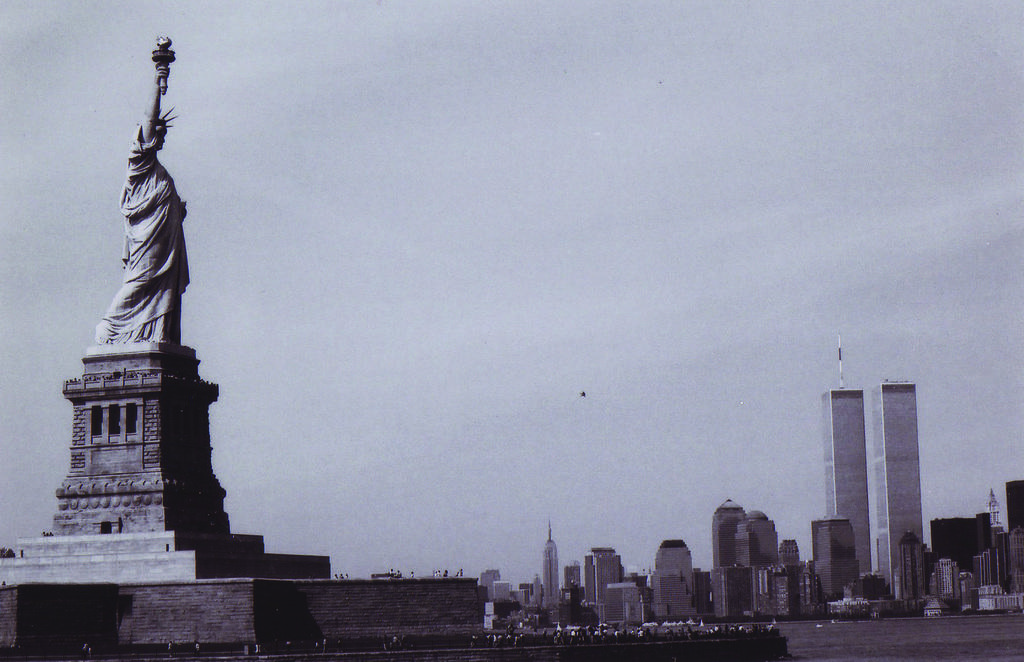What is the color scheme of the image? The image is black and white. What can be seen on the left side of the image? There is a statue on the left side of the image. What is visible in the background of the image? There are many buildings and the sky in the background of the image. What type of scarf is draped over the statue in the image? There is no scarf present on the statue in the image. Can you tell me how many church bells are ringing in the image? There is no church or church bells present in the image. 